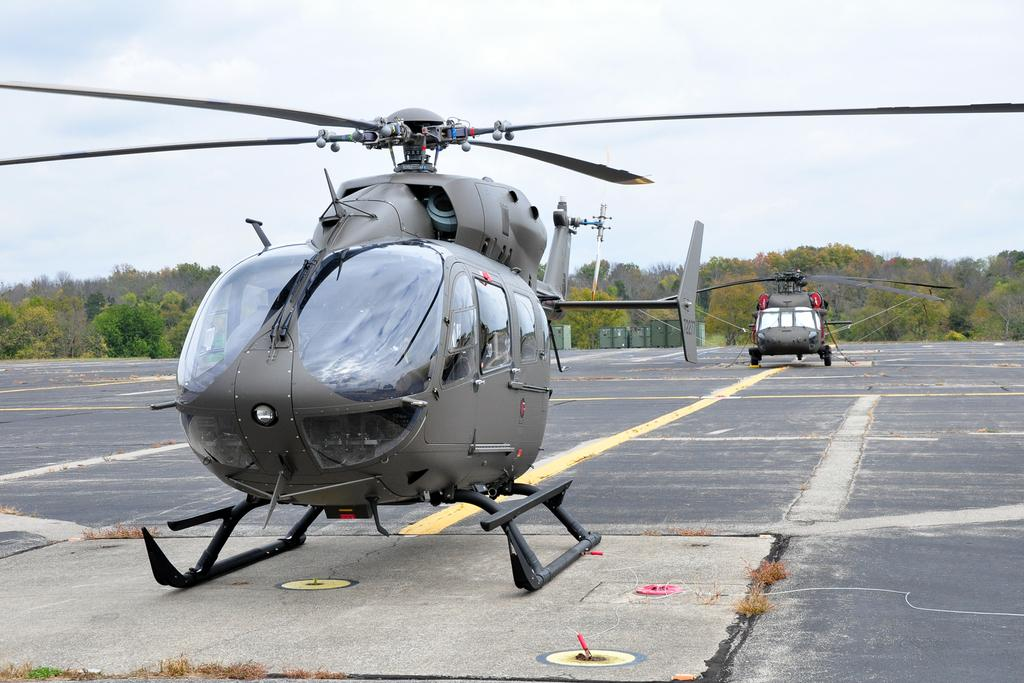How many helicopters are on the helipad in the image? There are two helicopters on the helipad in the image. What type of vegetation is visible in the image? There is grass visible in the image. What can be seen in the background of the image? Containers and a group of trees are visible in the background of the image. How would you describe the sky in the image? The sky is visible and appears cloudy in the image. How many tickets are required to ride in the helicopters in the image? There are no tickets mentioned or visible in the image, and the image does not show any activity related to riding in the helicopters. 